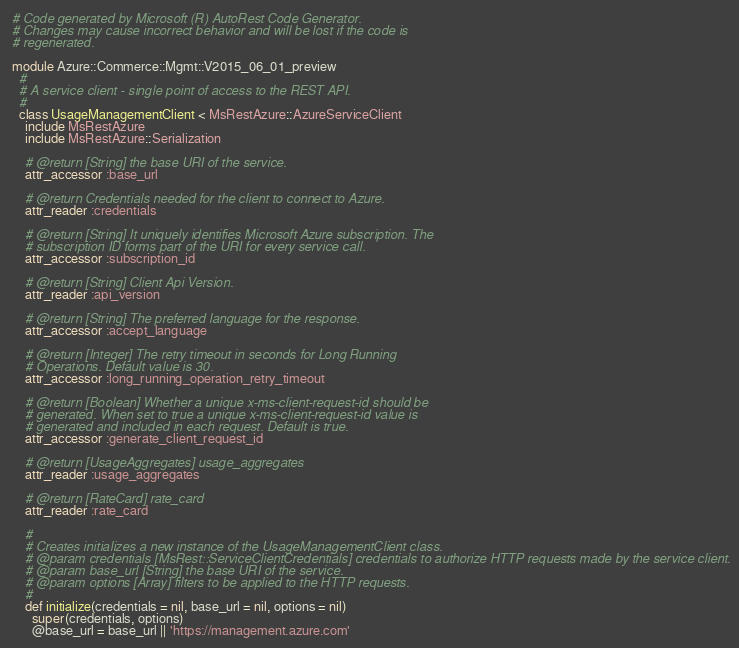Convert code to text. <code><loc_0><loc_0><loc_500><loc_500><_Ruby_># Code generated by Microsoft (R) AutoRest Code Generator.
# Changes may cause incorrect behavior and will be lost if the code is
# regenerated.

module Azure::Commerce::Mgmt::V2015_06_01_preview
  #
  # A service client - single point of access to the REST API.
  #
  class UsageManagementClient < MsRestAzure::AzureServiceClient
    include MsRestAzure
    include MsRestAzure::Serialization

    # @return [String] the base URI of the service.
    attr_accessor :base_url

    # @return Credentials needed for the client to connect to Azure.
    attr_reader :credentials

    # @return [String] It uniquely identifies Microsoft Azure subscription. The
    # subscription ID forms part of the URI for every service call.
    attr_accessor :subscription_id

    # @return [String] Client Api Version.
    attr_reader :api_version

    # @return [String] The preferred language for the response.
    attr_accessor :accept_language

    # @return [Integer] The retry timeout in seconds for Long Running
    # Operations. Default value is 30.
    attr_accessor :long_running_operation_retry_timeout

    # @return [Boolean] Whether a unique x-ms-client-request-id should be
    # generated. When set to true a unique x-ms-client-request-id value is
    # generated and included in each request. Default is true.
    attr_accessor :generate_client_request_id

    # @return [UsageAggregates] usage_aggregates
    attr_reader :usage_aggregates

    # @return [RateCard] rate_card
    attr_reader :rate_card

    #
    # Creates initializes a new instance of the UsageManagementClient class.
    # @param credentials [MsRest::ServiceClientCredentials] credentials to authorize HTTP requests made by the service client.
    # @param base_url [String] the base URI of the service.
    # @param options [Array] filters to be applied to the HTTP requests.
    #
    def initialize(credentials = nil, base_url = nil, options = nil)
      super(credentials, options)
      @base_url = base_url || 'https://management.azure.com'
</code> 